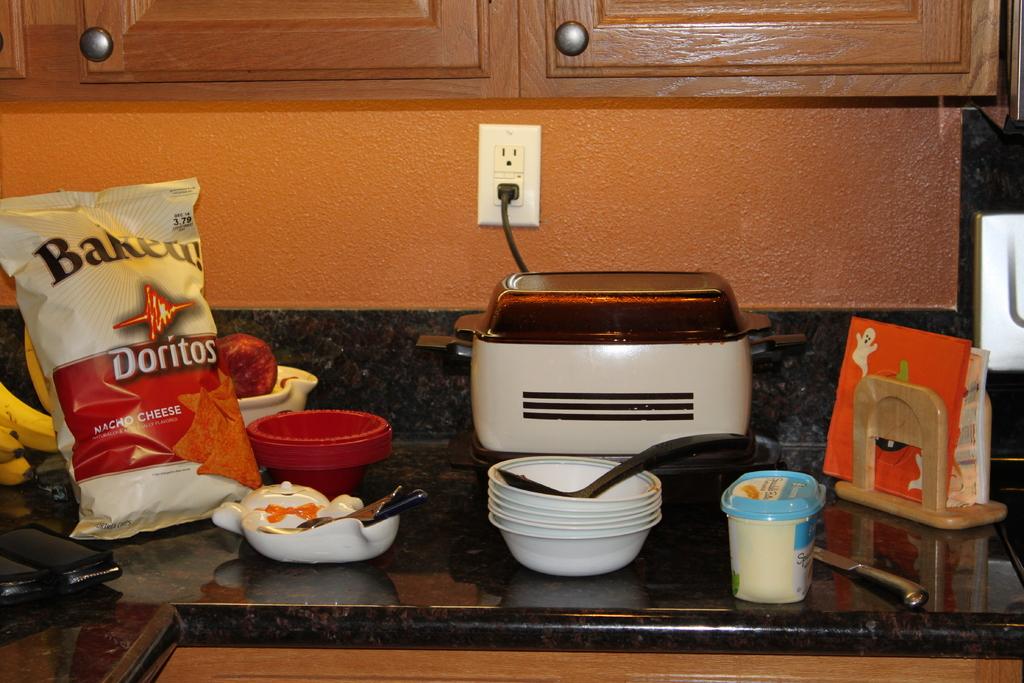What flavor doritos are on the cabinet?
Make the answer very short. Nacho cheese. What kind of doritos?
Your answer should be very brief. Baked. 